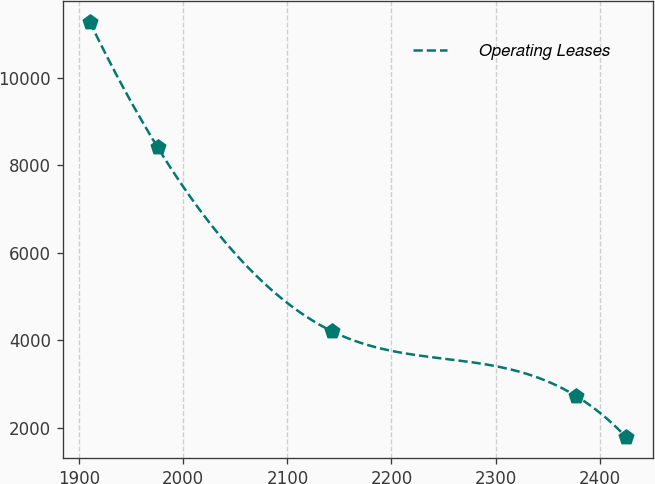<chart> <loc_0><loc_0><loc_500><loc_500><line_chart><ecel><fcel>Operating Leases<nl><fcel>1910.02<fcel>11280.7<nl><fcel>1975.42<fcel>8408.53<nl><fcel>2142.95<fcel>4208.68<nl><fcel>2377.15<fcel>2734.48<nl><fcel>2425.71<fcel>1784.9<nl></chart> 